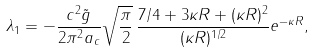<formula> <loc_0><loc_0><loc_500><loc_500>\lambda _ { 1 } = - \frac { c ^ { 2 } \tilde { g } } { 2 \pi ^ { 2 } a _ { c } } \sqrt { \frac { \pi } { 2 } } \, \frac { 7 / 4 + 3 \kappa R + ( \kappa R ) ^ { 2 } } { ( \kappa R ) ^ { 1 / 2 } } e ^ { - \kappa R } ,</formula> 